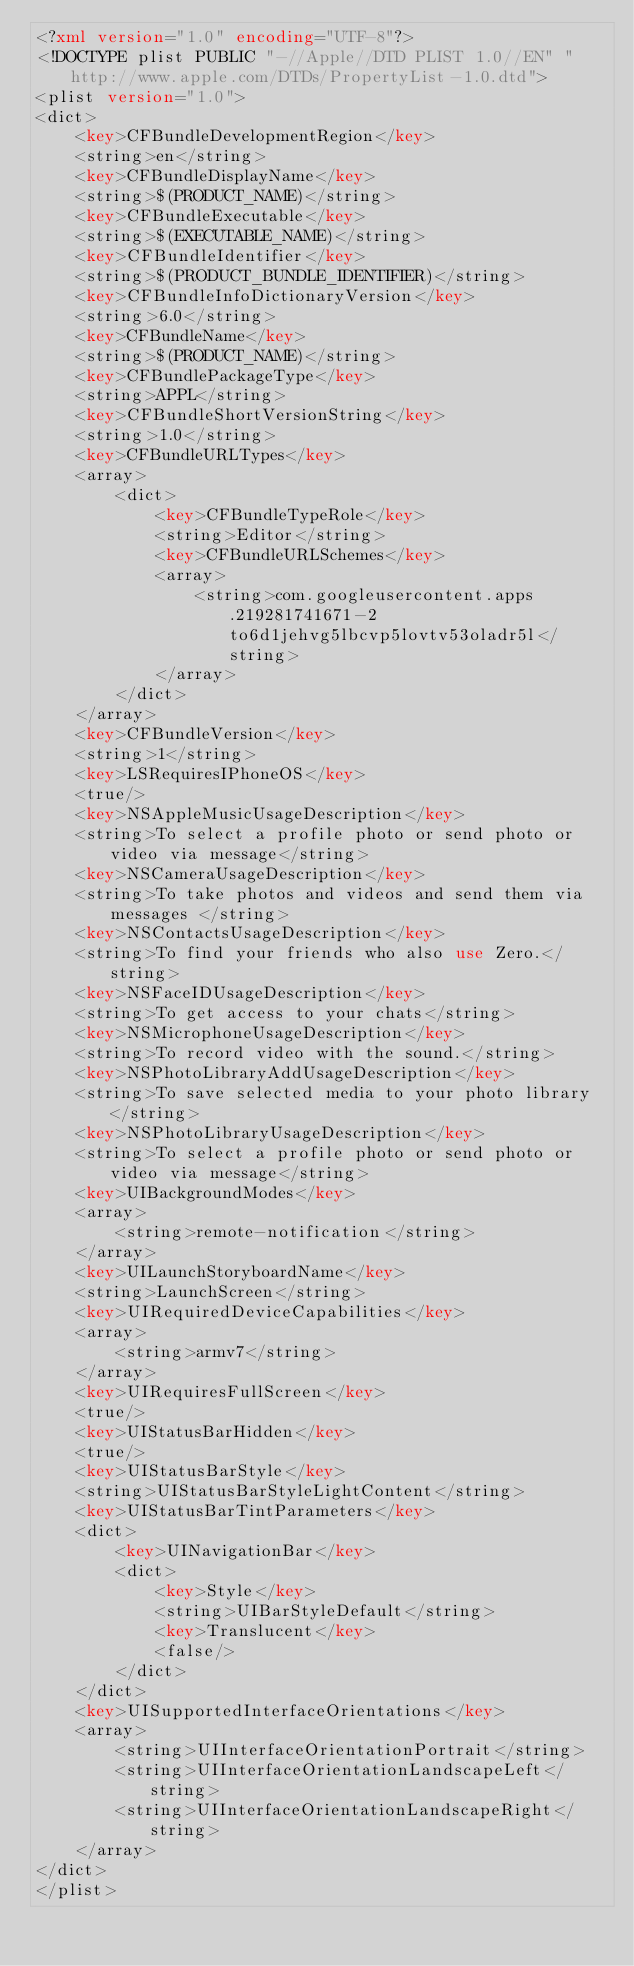<code> <loc_0><loc_0><loc_500><loc_500><_XML_><?xml version="1.0" encoding="UTF-8"?>
<!DOCTYPE plist PUBLIC "-//Apple//DTD PLIST 1.0//EN" "http://www.apple.com/DTDs/PropertyList-1.0.dtd">
<plist version="1.0">
<dict>
	<key>CFBundleDevelopmentRegion</key>
	<string>en</string>
	<key>CFBundleDisplayName</key>
	<string>$(PRODUCT_NAME)</string>
	<key>CFBundleExecutable</key>
	<string>$(EXECUTABLE_NAME)</string>
	<key>CFBundleIdentifier</key>
	<string>$(PRODUCT_BUNDLE_IDENTIFIER)</string>
	<key>CFBundleInfoDictionaryVersion</key>
	<string>6.0</string>
	<key>CFBundleName</key>
	<string>$(PRODUCT_NAME)</string>
	<key>CFBundlePackageType</key>
	<string>APPL</string>
	<key>CFBundleShortVersionString</key>
	<string>1.0</string>
	<key>CFBundleURLTypes</key>
	<array>
		<dict>
			<key>CFBundleTypeRole</key>
			<string>Editor</string>
			<key>CFBundleURLSchemes</key>
			<array>
				<string>com.googleusercontent.apps.219281741671-2to6d1jehvg5lbcvp5lovtv53oladr5l</string>
			</array>
		</dict>
	</array>
	<key>CFBundleVersion</key>
	<string>1</string>
	<key>LSRequiresIPhoneOS</key>
	<true/>
	<key>NSAppleMusicUsageDescription</key>
	<string>To select a profile photo or send photo or video via message</string>
	<key>NSCameraUsageDescription</key>
	<string>To take photos and videos and send them via messages </string>
	<key>NSContactsUsageDescription</key>
	<string>To find your friends who also use Zero.</string>
	<key>NSFaceIDUsageDescription</key>
	<string>To get access to your chats</string>
	<key>NSMicrophoneUsageDescription</key>
	<string>To record video with the sound.</string>
	<key>NSPhotoLibraryAddUsageDescription</key>
	<string>To save selected media to your photo library</string>
	<key>NSPhotoLibraryUsageDescription</key>
	<string>To select a profile photo or send photo or video via message</string>
	<key>UIBackgroundModes</key>
	<array>
		<string>remote-notification</string>
	</array>
	<key>UILaunchStoryboardName</key>
	<string>LaunchScreen</string>
	<key>UIRequiredDeviceCapabilities</key>
	<array>
		<string>armv7</string>
	</array>
	<key>UIRequiresFullScreen</key>
	<true/>
	<key>UIStatusBarHidden</key>
	<true/>
	<key>UIStatusBarStyle</key>
	<string>UIStatusBarStyleLightContent</string>
	<key>UIStatusBarTintParameters</key>
	<dict>
		<key>UINavigationBar</key>
		<dict>
			<key>Style</key>
			<string>UIBarStyleDefault</string>
			<key>Translucent</key>
			<false/>
		</dict>
	</dict>
	<key>UISupportedInterfaceOrientations</key>
	<array>
		<string>UIInterfaceOrientationPortrait</string>
		<string>UIInterfaceOrientationLandscapeLeft</string>
		<string>UIInterfaceOrientationLandscapeRight</string>
	</array>
</dict>
</plist>
</code> 